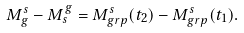<formula> <loc_0><loc_0><loc_500><loc_500>M _ { g } ^ { s } - M _ { s } ^ { g } = M _ { g r p } ^ { s } ( t _ { 2 } ) - M _ { g r p } ^ { s } ( t _ { 1 } ) .</formula> 